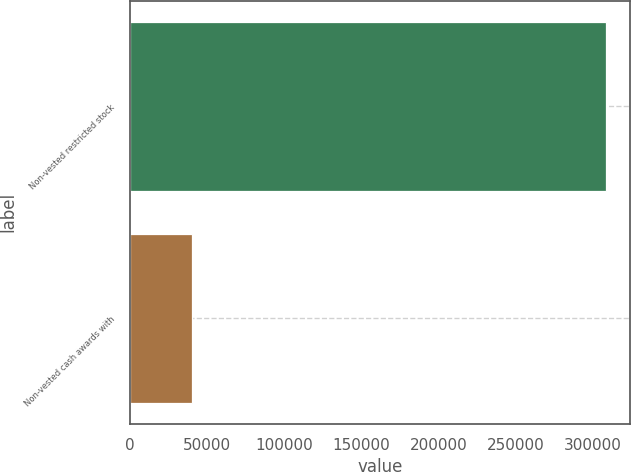Convert chart. <chart><loc_0><loc_0><loc_500><loc_500><bar_chart><fcel>Non-vested restricted stock<fcel>Non-vested cash awards with<nl><fcel>308700<fcel>39850<nl></chart> 